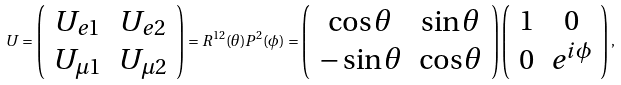Convert formula to latex. <formula><loc_0><loc_0><loc_500><loc_500>U = \left ( \begin{array} { c c } U _ { e 1 } & U _ { e 2 } \\ U _ { \mu 1 } & U _ { \mu 2 } \\ \end{array} \right ) = R ^ { 1 2 } ( \theta ) P ^ { 2 } ( \phi ) = \left ( \begin{array} { c c } \cos \theta & \sin \theta \\ - \sin \theta & \cos \theta \\ \end{array} \right ) \left ( \begin{array} { c c } 1 & 0 \\ 0 & e ^ { i \phi } \\ \end{array} \right ) ,</formula> 